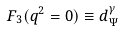<formula> <loc_0><loc_0><loc_500><loc_500>F _ { 3 } ( q ^ { 2 } = 0 ) \equiv d _ { \Psi } ^ { \gamma }</formula> 